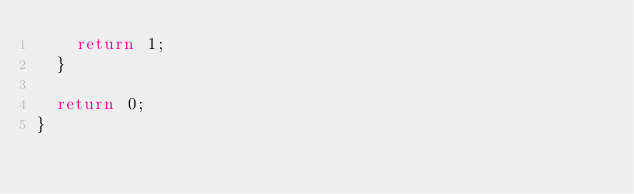<code> <loc_0><loc_0><loc_500><loc_500><_C++_>    return 1;
  }

  return 0;
}
</code> 